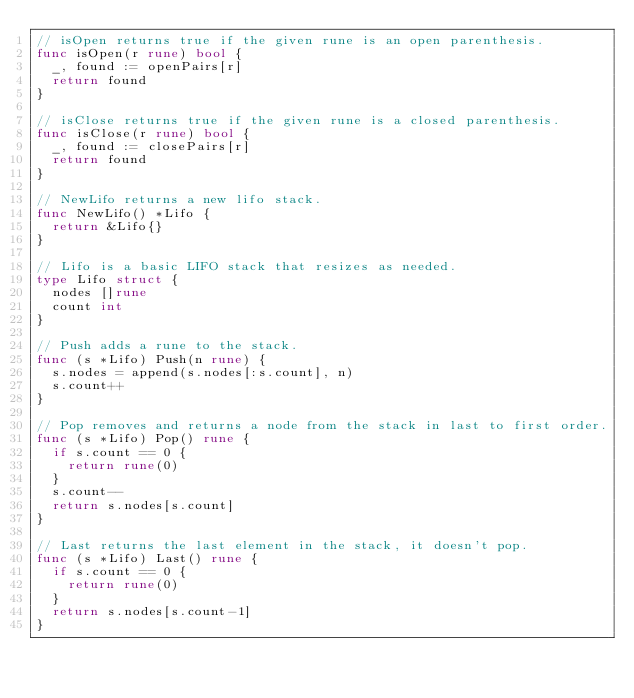Convert code to text. <code><loc_0><loc_0><loc_500><loc_500><_Go_>// isOpen returns true if the given rune is an open parenthesis.
func isOpen(r rune) bool {
	_, found := openPairs[r]
	return found
}

// isClose returns true if the given rune is a closed parenthesis.
func isClose(r rune) bool {
	_, found := closePairs[r]
	return found
}

// NewLifo returns a new lifo stack.
func NewLifo() *Lifo {
	return &Lifo{}
}

// Lifo is a basic LIFO stack that resizes as needed.
type Lifo struct {
	nodes []rune
	count int
}

// Push adds a rune to the stack.
func (s *Lifo) Push(n rune) {
	s.nodes = append(s.nodes[:s.count], n)
	s.count++
}

// Pop removes and returns a node from the stack in last to first order.
func (s *Lifo) Pop() rune {
	if s.count == 0 {
		return rune(0)
	}
	s.count--
	return s.nodes[s.count]
}

// Last returns the last element in the stack, it doesn't pop.
func (s *Lifo) Last() rune {
	if s.count == 0 {
		return rune(0)
	}
	return s.nodes[s.count-1]
}
</code> 